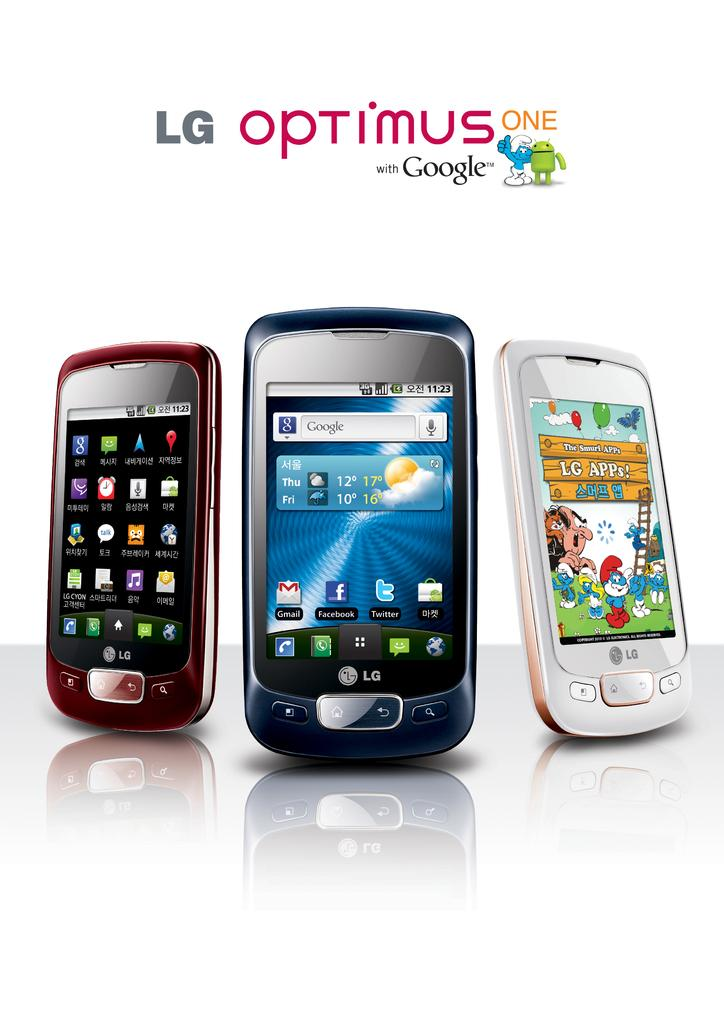<image>
Offer a succinct explanation of the picture presented. Three cellphones models from LG are named optimus one. 